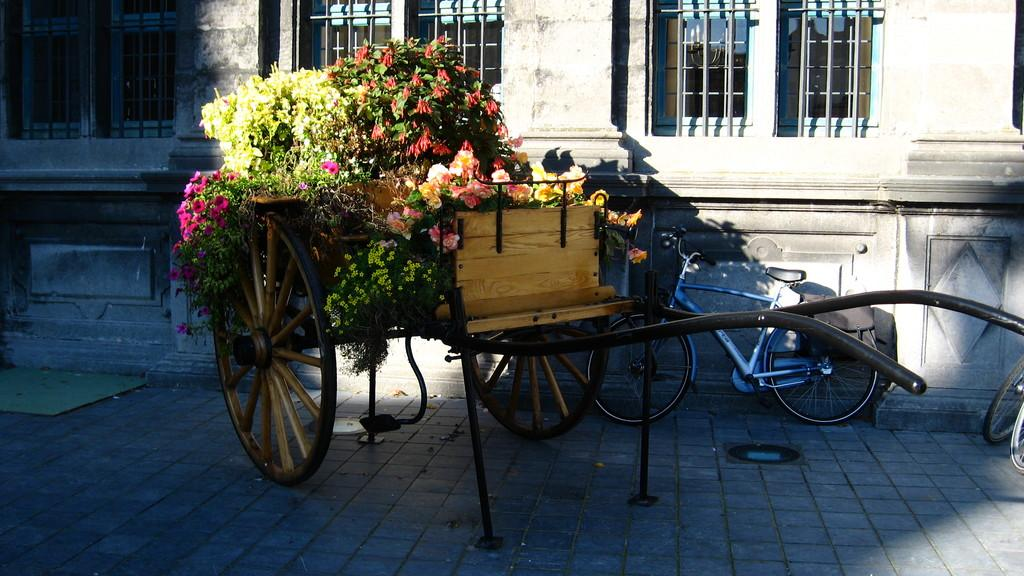What is on the floor in the image? There is a cart on the floor in the image. What is inside the cart's carriage? The cart's carriage is filled with plants and flowers. What can be seen in the background of the image? There is a building, windows, and bicycles visible in the background of the image. What type of oatmeal is being served in the image? There is no oatmeal present in the image; it features a cart filled with plants and flowers. What suggestion can be made to improve the arrangement of the plants in the cart? The image does not provide enough information to make a suggestion for improving the arrangement of the plants in the cart. 